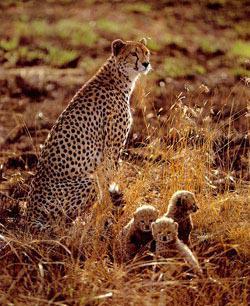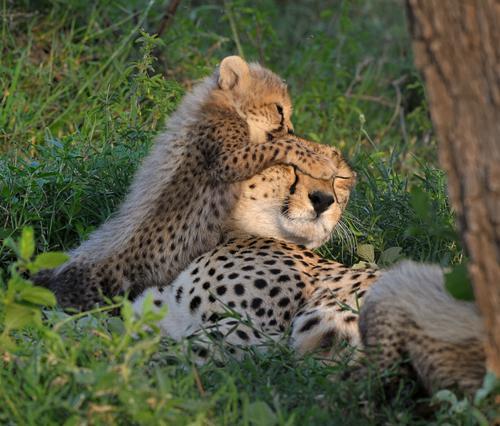The first image is the image on the left, the second image is the image on the right. Analyze the images presented: Is the assertion "An image shows four cheetahs grouped on a dirt mound, with at least one of them reclining." valid? Answer yes or no. No. 